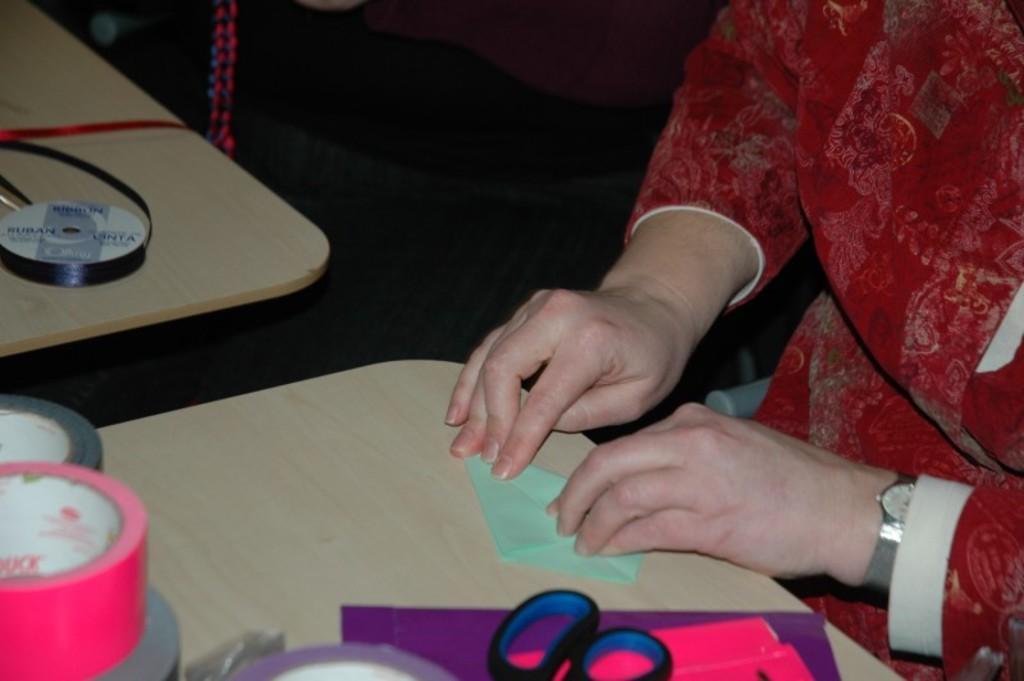Please provide a concise description of this image. In the image there is a woman she is folding a paper and beside the paper there are other craft items and on the right side there is another table and on that table there is a ribbon. 